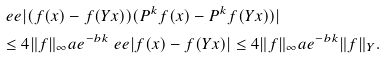<formula> <loc_0><loc_0><loc_500><loc_500>& \ e e | ( f ( x ) - f ( Y x ) ) ( P ^ { k } f ( x ) - P ^ { k } f ( Y x ) ) | \\ & \leq 4 \| f \| _ { \infty } a e ^ { - b k } \ e e | f ( x ) - f ( Y x ) | \leq 4 \| f \| _ { \infty } a e ^ { - b k } \| f \| _ { Y } .</formula> 